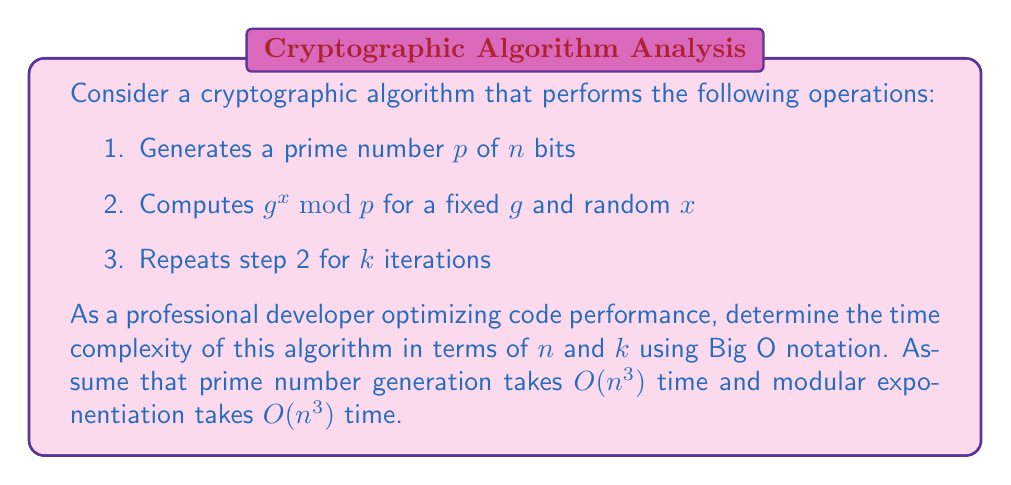Provide a solution to this math problem. Let's break down the algorithm and analyze each step:

1. Prime number generation:
   - Generating a prime number of $n$ bits takes $O(n^3)$ time.

2. Modular exponentiation:
   - Computing $g^x \bmod p$ takes $O(n^3)$ time.

3. Repetition:
   - Step 2 is repeated $k$ times.

Now, let's combine these steps:

1. Prime number generation is performed once: $O(n^3)$
2. Modular exponentiation is performed $k$ times: $k \cdot O(n^3)$

The total time complexity is the sum of these operations:

$$O(n^3) + k \cdot O(n^3)$$

Simplifying this expression:

$$O(n^3) + O(kn^3) = O((k+1)n^3)$$

Since we're interested in the asymptotic behavior, we can further simplify this to:

$$O(kn^3)$$

This is because as $n$ and $k$ grow, the constant factor of 1 becomes insignificant compared to $k$.
Answer: $O(kn^3)$ 